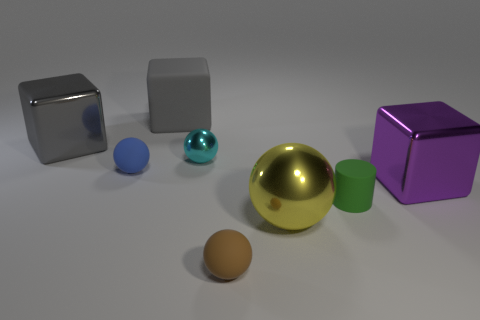Add 2 tiny brown spheres. How many objects exist? 10 Subtract all brown balls. How many balls are left? 3 Subtract all big purple blocks. How many blocks are left? 2 Subtract 1 cyan balls. How many objects are left? 7 Subtract all cubes. How many objects are left? 5 Subtract 2 blocks. How many blocks are left? 1 Subtract all red cubes. Subtract all gray spheres. How many cubes are left? 3 Subtract all cyan cylinders. How many blue blocks are left? 0 Subtract all spheres. Subtract all green cylinders. How many objects are left? 3 Add 7 matte balls. How many matte balls are left? 9 